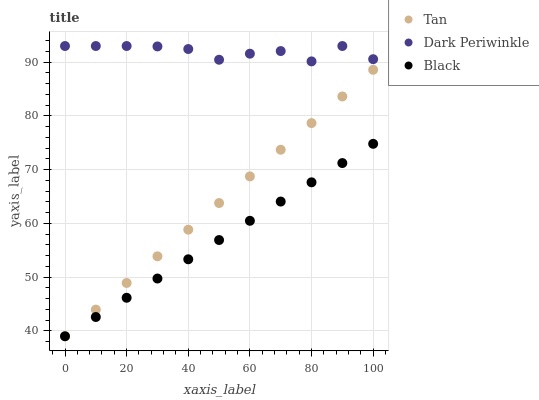Does Black have the minimum area under the curve?
Answer yes or no. Yes. Does Dark Periwinkle have the maximum area under the curve?
Answer yes or no. Yes. Does Dark Periwinkle have the minimum area under the curve?
Answer yes or no. No. Does Black have the maximum area under the curve?
Answer yes or no. No. Is Black the smoothest?
Answer yes or no. Yes. Is Dark Periwinkle the roughest?
Answer yes or no. Yes. Is Dark Periwinkle the smoothest?
Answer yes or no. No. Is Black the roughest?
Answer yes or no. No. Does Tan have the lowest value?
Answer yes or no. Yes. Does Dark Periwinkle have the lowest value?
Answer yes or no. No. Does Dark Periwinkle have the highest value?
Answer yes or no. Yes. Does Black have the highest value?
Answer yes or no. No. Is Tan less than Dark Periwinkle?
Answer yes or no. Yes. Is Dark Periwinkle greater than Black?
Answer yes or no. Yes. Does Black intersect Tan?
Answer yes or no. Yes. Is Black less than Tan?
Answer yes or no. No. Is Black greater than Tan?
Answer yes or no. No. Does Tan intersect Dark Periwinkle?
Answer yes or no. No. 